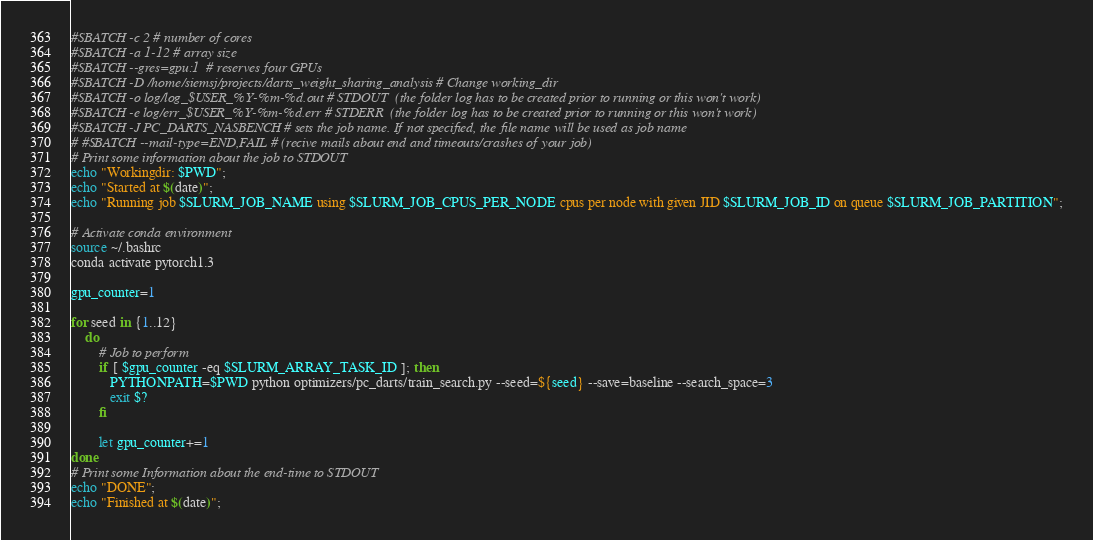<code> <loc_0><loc_0><loc_500><loc_500><_Bash_>#SBATCH -c 2 # number of cores
#SBATCH -a 1-12 # array size
#SBATCH --gres=gpu:1  # reserves four GPUs
#SBATCH -D /home/siemsj/projects/darts_weight_sharing_analysis # Change working_dir
#SBATCH -o log/log_$USER_%Y-%m-%d.out # STDOUT  (the folder log has to be created prior to running or this won't work)
#SBATCH -e log/err_$USER_%Y-%m-%d.err # STDERR  (the folder log has to be created prior to running or this won't work)
#SBATCH -J PC_DARTS_NASBENCH # sets the job name. If not specified, the file name will be used as job name
# #SBATCH --mail-type=END,FAIL # (recive mails about end and timeouts/crashes of your job)
# Print some information about the job to STDOUT
echo "Workingdir: $PWD";
echo "Started at $(date)";
echo "Running job $SLURM_JOB_NAME using $SLURM_JOB_CPUS_PER_NODE cpus per node with given JID $SLURM_JOB_ID on queue $SLURM_JOB_PARTITION";

# Activate conda environment
source ~/.bashrc
conda activate pytorch1.3

gpu_counter=1

for seed in {1..12}
    do
        # Job to perform
        if [ $gpu_counter -eq $SLURM_ARRAY_TASK_ID ]; then
           PYTHONPATH=$PWD python optimizers/pc_darts/train_search.py --seed=${seed} --save=baseline --search_space=3
           exit $?
        fi

        let gpu_counter+=1
done
# Print some Information about the end-time to STDOUT
echo "DONE";
echo "Finished at $(date)";</code> 